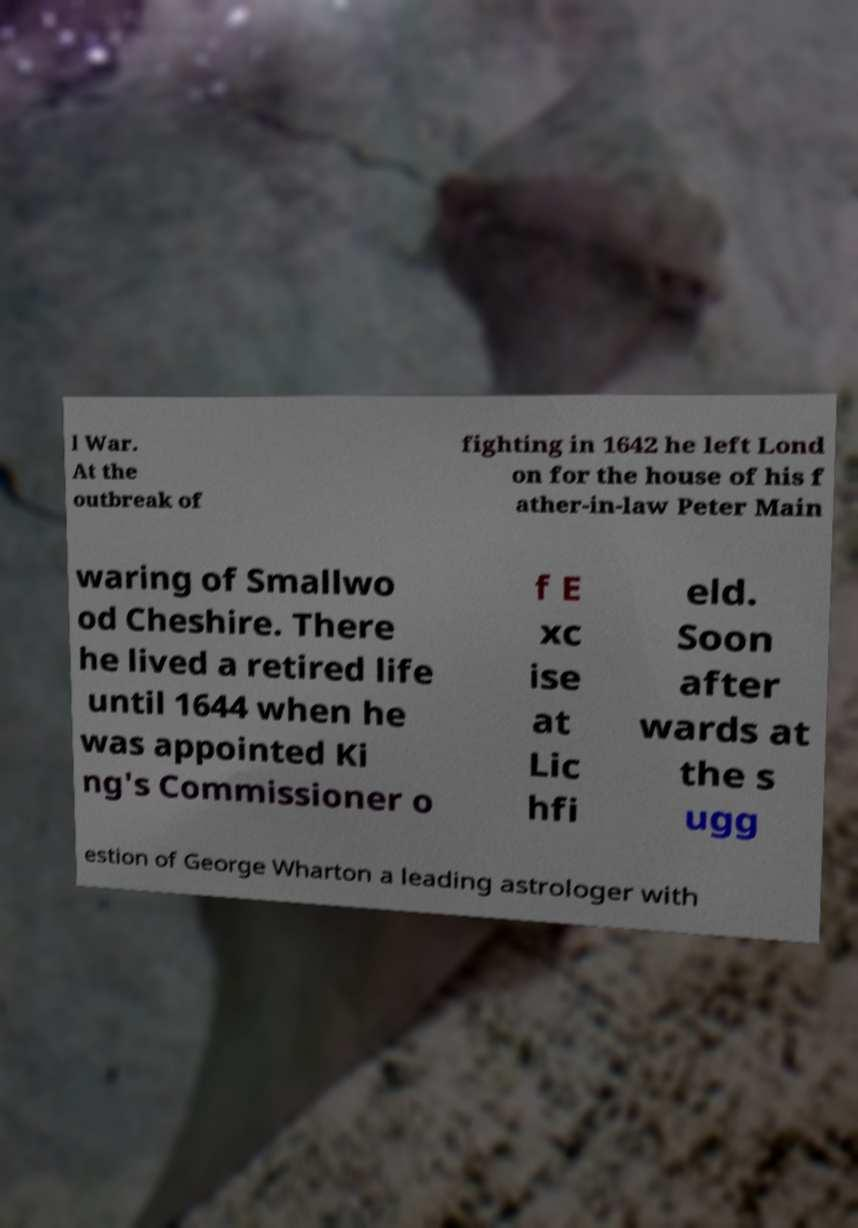Can you accurately transcribe the text from the provided image for me? l War. At the outbreak of fighting in 1642 he left Lond on for the house of his f ather-in-law Peter Main waring of Smallwo od Cheshire. There he lived a retired life until 1644 when he was appointed Ki ng's Commissioner o f E xc ise at Lic hfi eld. Soon after wards at the s ugg estion of George Wharton a leading astrologer with 